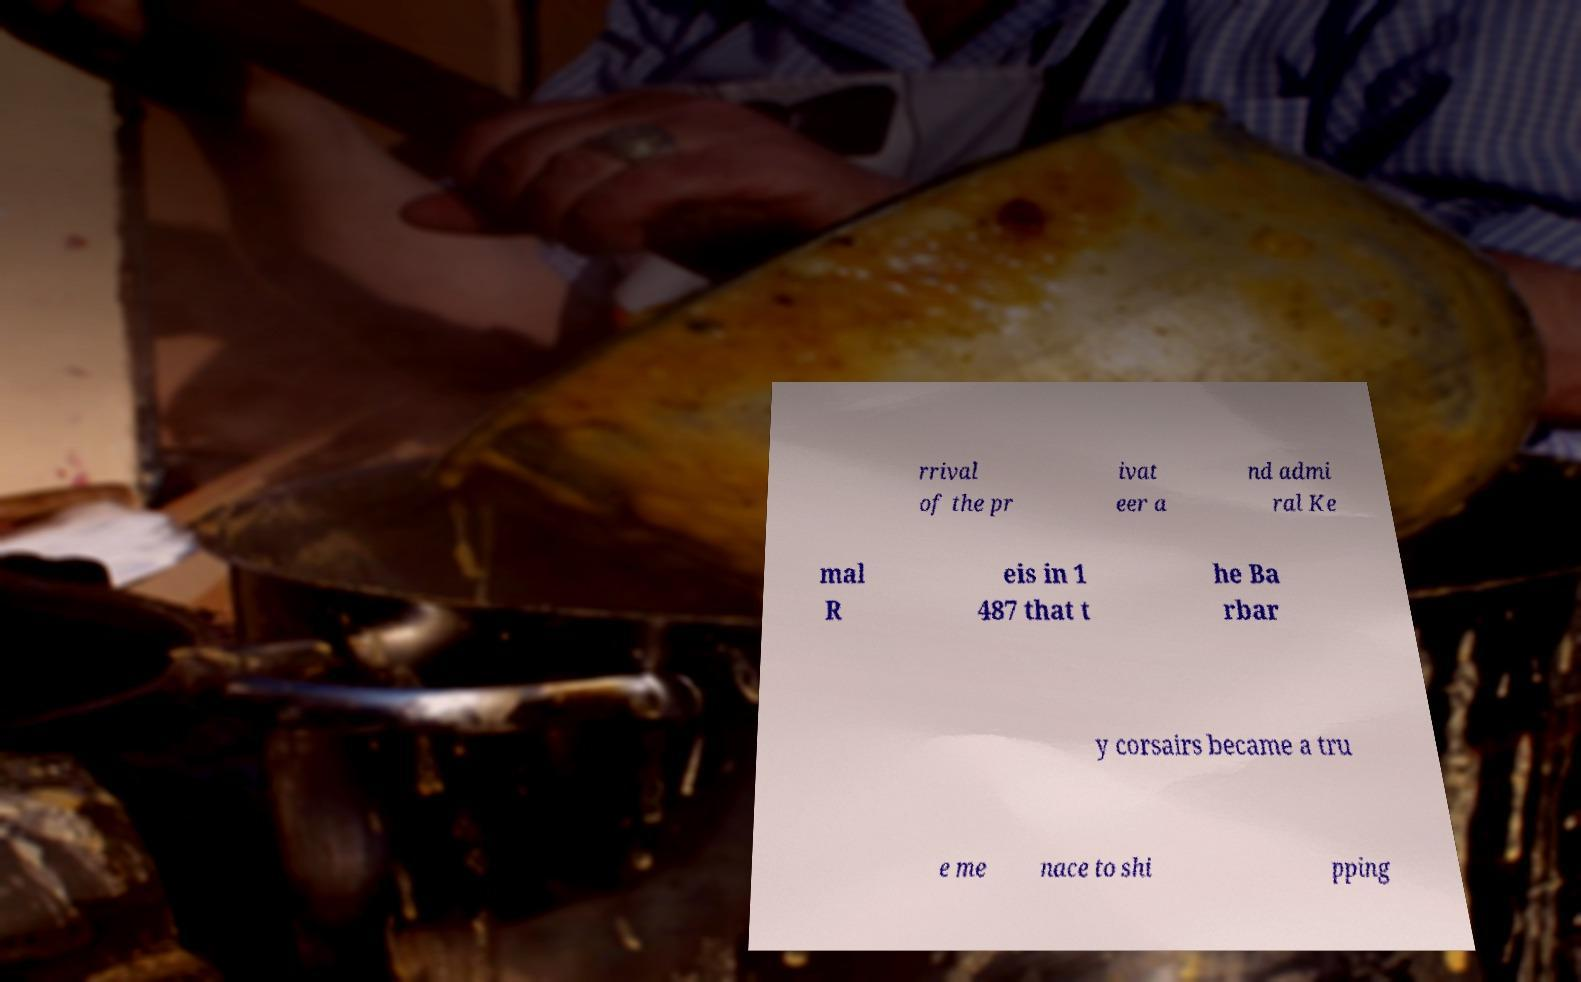Can you accurately transcribe the text from the provided image for me? rrival of the pr ivat eer a nd admi ral Ke mal R eis in 1 487 that t he Ba rbar y corsairs became a tru e me nace to shi pping 